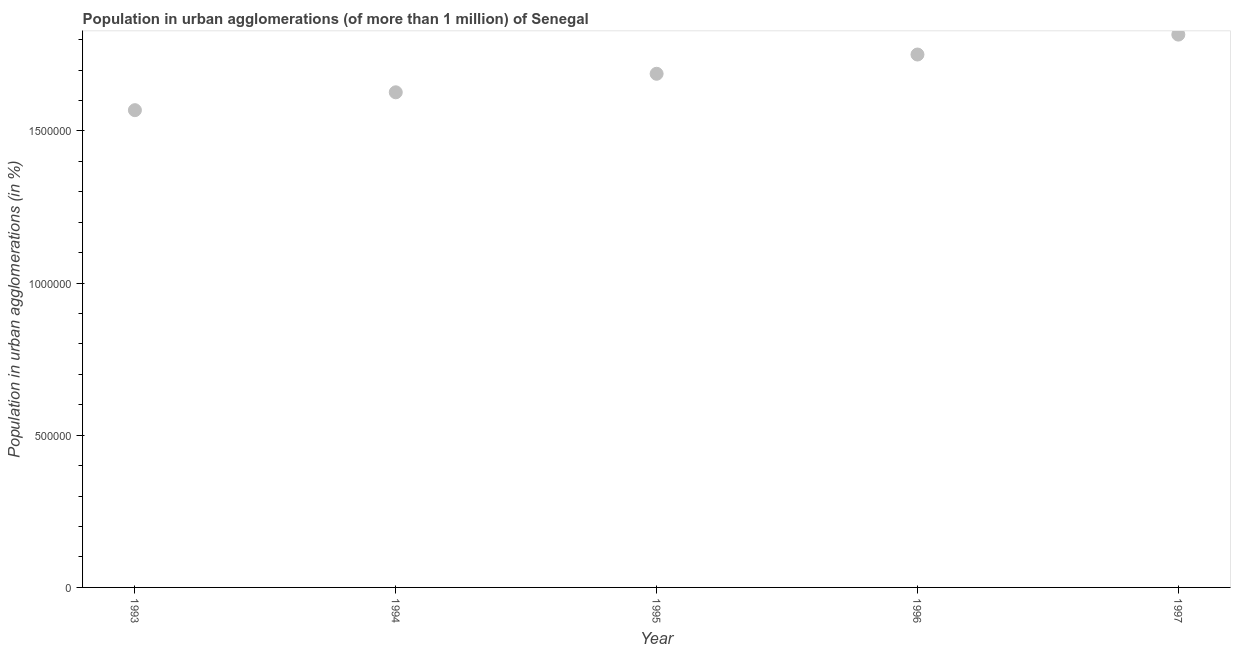What is the population in urban agglomerations in 1997?
Make the answer very short. 1.82e+06. Across all years, what is the maximum population in urban agglomerations?
Your answer should be compact. 1.82e+06. Across all years, what is the minimum population in urban agglomerations?
Ensure brevity in your answer.  1.57e+06. In which year was the population in urban agglomerations minimum?
Your answer should be compact. 1993. What is the sum of the population in urban agglomerations?
Your answer should be very brief. 8.45e+06. What is the difference between the population in urban agglomerations in 1994 and 1995?
Your response must be concise. -6.09e+04. What is the average population in urban agglomerations per year?
Your response must be concise. 1.69e+06. What is the median population in urban agglomerations?
Your response must be concise. 1.69e+06. What is the ratio of the population in urban agglomerations in 1996 to that in 1997?
Offer a terse response. 0.96. Is the difference between the population in urban agglomerations in 1994 and 1995 greater than the difference between any two years?
Provide a succinct answer. No. What is the difference between the highest and the second highest population in urban agglomerations?
Provide a succinct answer. 6.55e+04. Is the sum of the population in urban agglomerations in 1995 and 1997 greater than the maximum population in urban agglomerations across all years?
Your response must be concise. Yes. What is the difference between the highest and the lowest population in urban agglomerations?
Your response must be concise. 2.48e+05. Does the population in urban agglomerations monotonically increase over the years?
Offer a very short reply. Yes. How many years are there in the graph?
Your answer should be compact. 5. Does the graph contain any zero values?
Give a very brief answer. No. What is the title of the graph?
Provide a succinct answer. Population in urban agglomerations (of more than 1 million) of Senegal. What is the label or title of the Y-axis?
Your response must be concise. Population in urban agglomerations (in %). What is the Population in urban agglomerations (in %) in 1993?
Your response must be concise. 1.57e+06. What is the Population in urban agglomerations (in %) in 1994?
Offer a very short reply. 1.63e+06. What is the Population in urban agglomerations (in %) in 1995?
Offer a terse response. 1.69e+06. What is the Population in urban agglomerations (in %) in 1996?
Give a very brief answer. 1.75e+06. What is the Population in urban agglomerations (in %) in 1997?
Your response must be concise. 1.82e+06. What is the difference between the Population in urban agglomerations (in %) in 1993 and 1994?
Your response must be concise. -5.87e+04. What is the difference between the Population in urban agglomerations (in %) in 1993 and 1995?
Provide a short and direct response. -1.20e+05. What is the difference between the Population in urban agglomerations (in %) in 1993 and 1996?
Ensure brevity in your answer.  -1.83e+05. What is the difference between the Population in urban agglomerations (in %) in 1993 and 1997?
Keep it short and to the point. -2.48e+05. What is the difference between the Population in urban agglomerations (in %) in 1994 and 1995?
Provide a succinct answer. -6.09e+04. What is the difference between the Population in urban agglomerations (in %) in 1994 and 1996?
Keep it short and to the point. -1.24e+05. What is the difference between the Population in urban agglomerations (in %) in 1994 and 1997?
Provide a short and direct response. -1.90e+05. What is the difference between the Population in urban agglomerations (in %) in 1995 and 1996?
Your response must be concise. -6.33e+04. What is the difference between the Population in urban agglomerations (in %) in 1995 and 1997?
Make the answer very short. -1.29e+05. What is the difference between the Population in urban agglomerations (in %) in 1996 and 1997?
Give a very brief answer. -6.55e+04. What is the ratio of the Population in urban agglomerations (in %) in 1993 to that in 1994?
Your answer should be compact. 0.96. What is the ratio of the Population in urban agglomerations (in %) in 1993 to that in 1995?
Your answer should be compact. 0.93. What is the ratio of the Population in urban agglomerations (in %) in 1993 to that in 1996?
Keep it short and to the point. 0.9. What is the ratio of the Population in urban agglomerations (in %) in 1993 to that in 1997?
Make the answer very short. 0.86. What is the ratio of the Population in urban agglomerations (in %) in 1994 to that in 1996?
Offer a terse response. 0.93. What is the ratio of the Population in urban agglomerations (in %) in 1994 to that in 1997?
Provide a short and direct response. 0.9. What is the ratio of the Population in urban agglomerations (in %) in 1995 to that in 1997?
Your response must be concise. 0.93. What is the ratio of the Population in urban agglomerations (in %) in 1996 to that in 1997?
Provide a short and direct response. 0.96. 